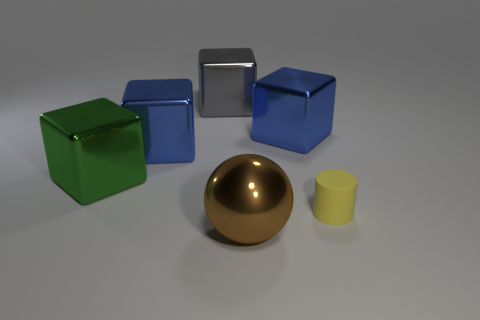Are there any patterns or consitencies in the arrangement of the objects? The arrangement of objects in the image doesn't demonstrate a clear pattern in terms of positioning. However, the objects do seem to share a consistent theme in their basic geometric shapes — comprising of spheres, cubes, and a cylinder. They are spaced out across the surface, which may highlight their individual shapes and colors more distinctly. 